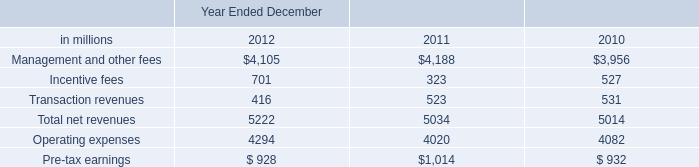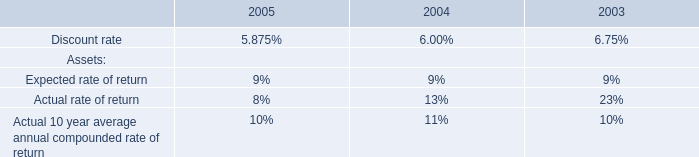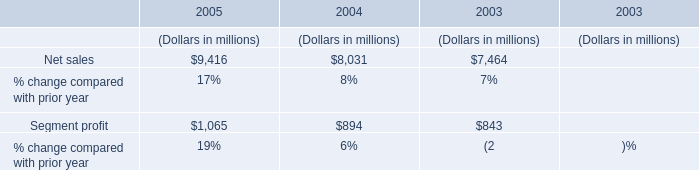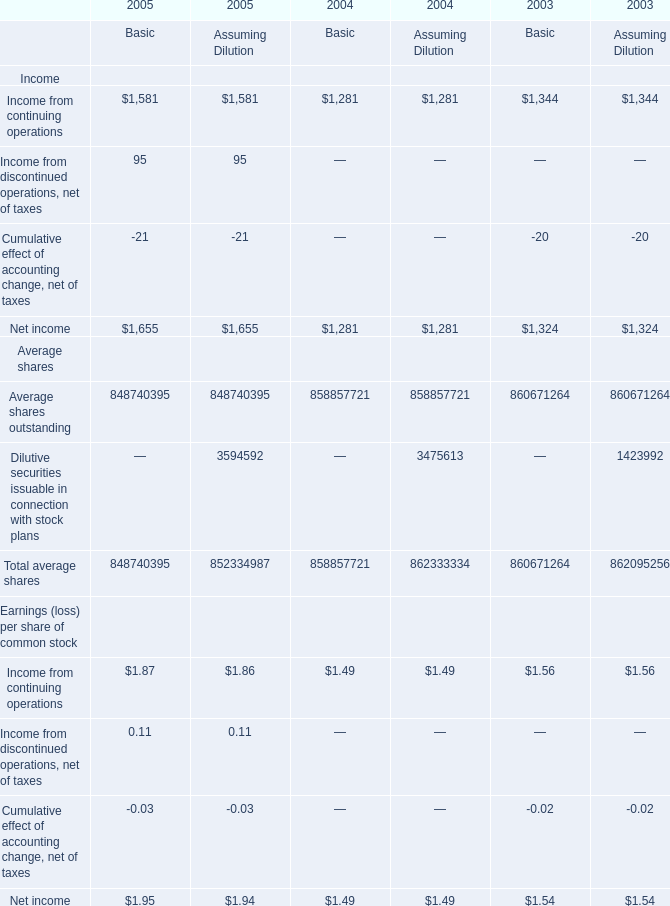What's the increasing rate of Income from continuing operations for Basic in 2005? (in %) 
Computations: ((1581 - 1281) / 1281)
Answer: 0.23419. 